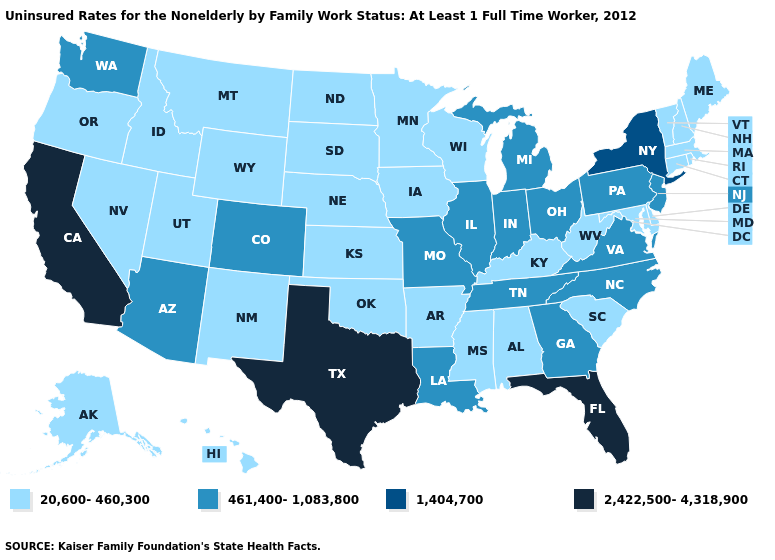Is the legend a continuous bar?
Answer briefly. No. Does Tennessee have the highest value in the USA?
Answer briefly. No. Among the states that border Delaware , which have the lowest value?
Write a very short answer. Maryland. What is the lowest value in the USA?
Be succinct. 20,600-460,300. What is the value of Delaware?
Keep it brief. 20,600-460,300. What is the value of Georgia?
Keep it brief. 461,400-1,083,800. Does New Mexico have the highest value in the West?
Concise answer only. No. Among the states that border New Jersey , does New York have the highest value?
Short answer required. Yes. What is the value of California?
Keep it brief. 2,422,500-4,318,900. What is the value of New Jersey?
Answer briefly. 461,400-1,083,800. Name the states that have a value in the range 461,400-1,083,800?
Write a very short answer. Arizona, Colorado, Georgia, Illinois, Indiana, Louisiana, Michigan, Missouri, New Jersey, North Carolina, Ohio, Pennsylvania, Tennessee, Virginia, Washington. Which states have the lowest value in the West?
Write a very short answer. Alaska, Hawaii, Idaho, Montana, Nevada, New Mexico, Oregon, Utah, Wyoming. Name the states that have a value in the range 2,422,500-4,318,900?
Concise answer only. California, Florida, Texas. 